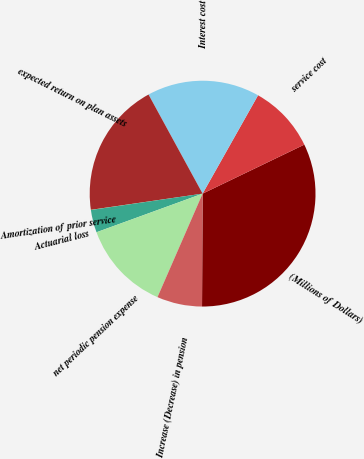<chart> <loc_0><loc_0><loc_500><loc_500><pie_chart><fcel>(Millions of Dollars)<fcel>service cost<fcel>Interest cost<fcel>expected return on plan assets<fcel>Amortization of prior service<fcel>Actuarial loss<fcel>net periodic pension expense<fcel>Increase (Decrease) in pension<nl><fcel>32.22%<fcel>9.68%<fcel>16.12%<fcel>19.34%<fcel>0.02%<fcel>3.24%<fcel>12.9%<fcel>6.46%<nl></chart> 